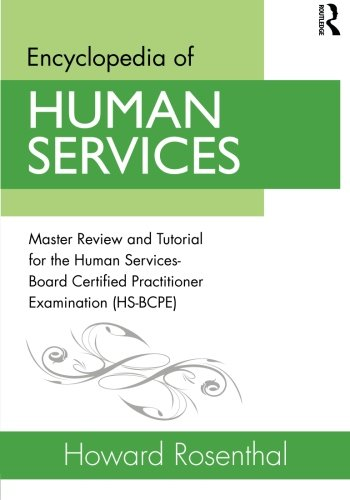Could you explain why might this book be considered a reliable source? Based on the author, Howard Rosenthal, being a renowned figure in the field, and the detailed nature of the content geared toward certification examination, this book can be considered a reliable source for those studying or working in the human services industry. 